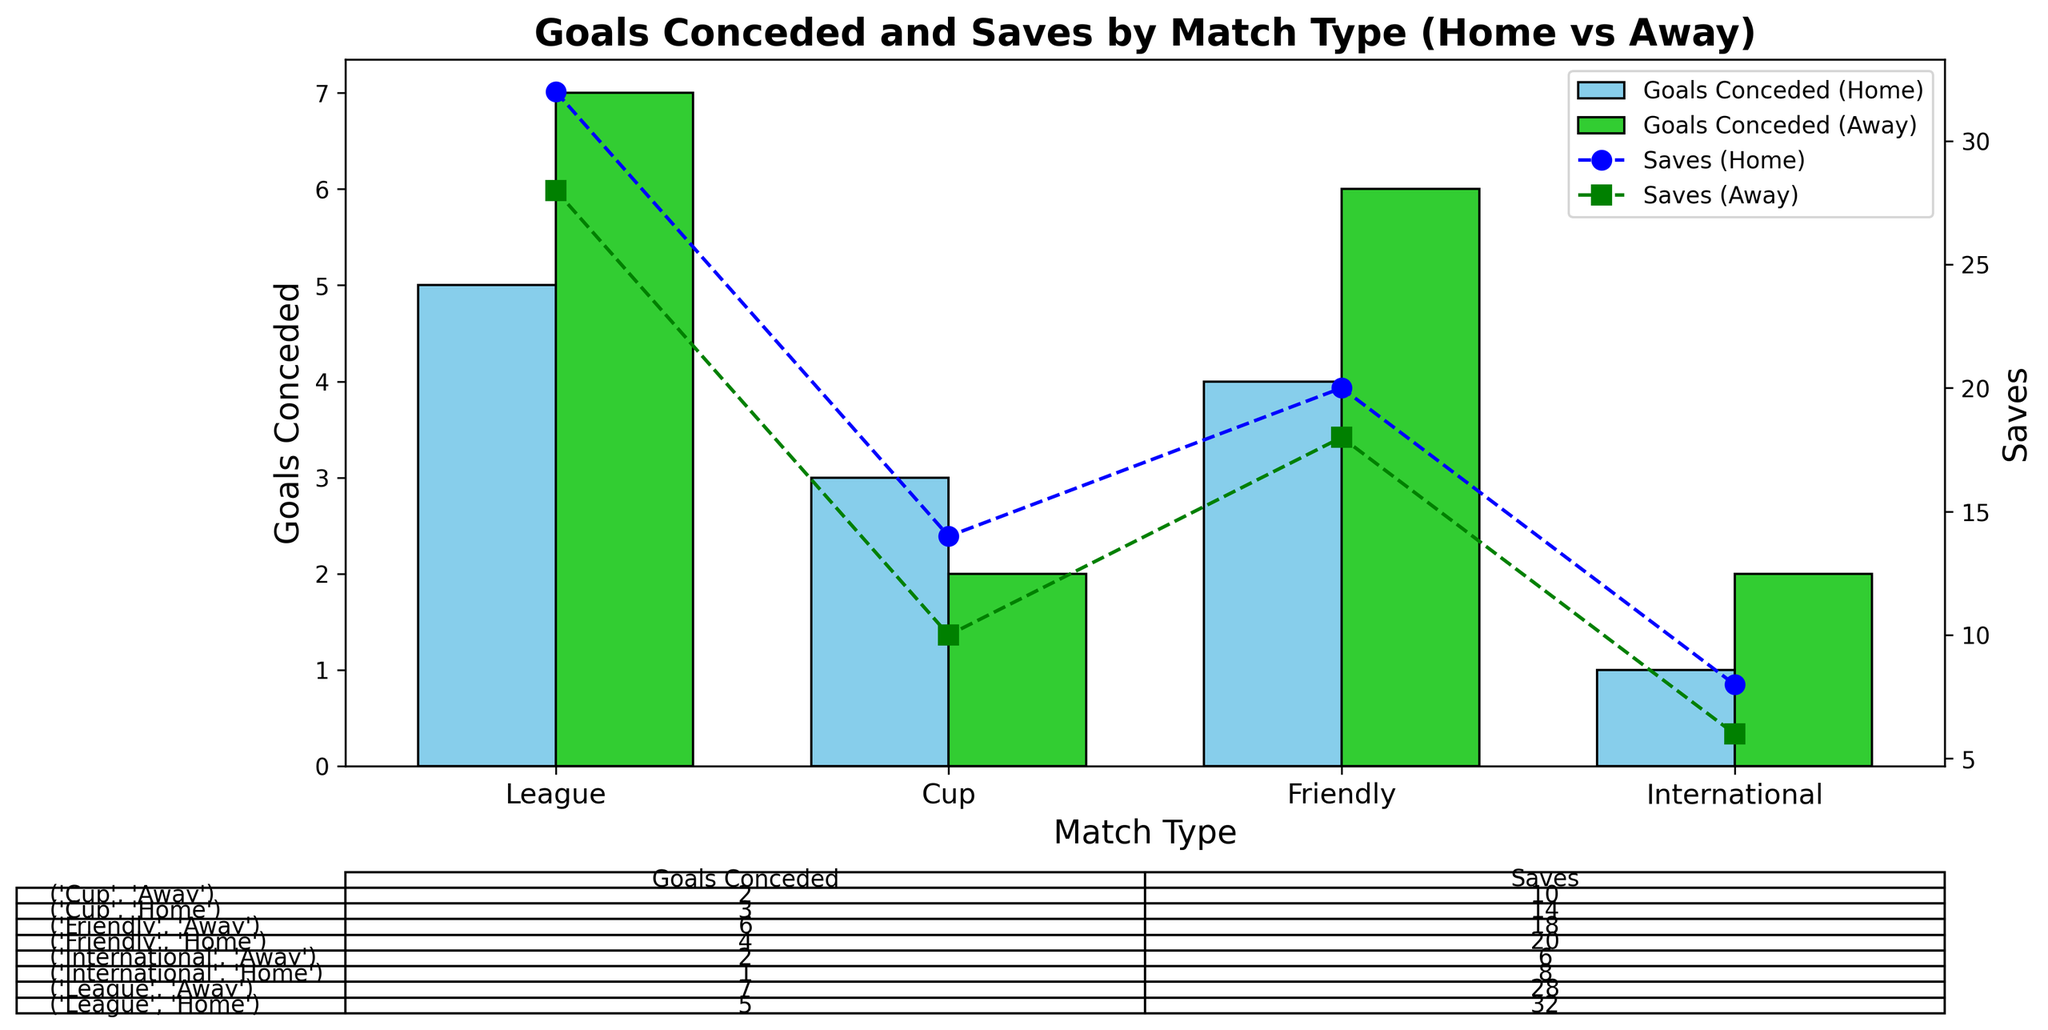What is the total number of goals conceded in League matches? The number of goals conceded in League matches is the sum of goals conceded at home and away. From the chart, it's 5 (home) + 7 (away).
Answer: 12 Which match type had the fewest saves at home? Look at the home saves (blue markers) for each match type. The International match type had the fewest home saves with 8.
Answer: International How does the number of goals conceded compare between home and away for Friendlies? Look at the bars for Friendlies in the plot. The home goals conceded (sky blue) is 4 and the away goals conceded (lime green) is 6. Home is less than away by 2.
Answer: Home < Away What is the combined total of saves in Cup matches? The number of saves in Cup matches is the total of saves at home and away. From the chart, it's 14 (home) + 10 (away).
Answer: 24 Which match type had the highest number of goals conceded at home? Look at the home goals conceded (sky blue bars) for each match type. League matches had the highest with 5 goals.
Answer: League Is the number of saves greater in home or away League matches? Compare the home saves (blue markers, 32) and away saves (green markers, 28) for League matches. Home saves are greater.
Answer: Home In which category (home/away) and match type is the discrepancy between goals conceded and saves the largest? Calculate the discrepancy (difference) between goals conceded and saves for each home and away category in all match types. The largest discrepancy is for League home matches with a difference of 27 (32 saves - 5 goals).
Answer: League Home What percentage of total goals conceded in Friendly matches happened away? Calculate total goals conceded in Friendly matches: 4 (home) + 6 (away) = 10. The percentage away is (6/10) * 100 = 60%.
Answer: 60% What's the average number of saves in Friendly matches? Combine the saves for Friendly matches (home and away): 20 (home) + 18 (away) = 38. The average is 38 / 2 = 19.
Answer: 19 By how much do home saves differ from away saves in International matches? Compare the home saves (8) and away saves (6) in International matches. The difference is 8 - 6.
Answer: 2 